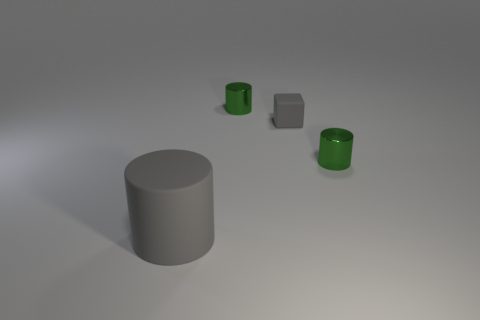Is the size of the gray cylinder the same as the gray cube?
Your answer should be very brief. No. Do the large cylinder and the small cylinder left of the block have the same material?
Keep it short and to the point. No. There is a matte thing that is on the right side of the gray cylinder; is its color the same as the matte cylinder?
Your answer should be compact. Yes. Is the green object that is behind the small rubber thing made of the same material as the small gray cube?
Keep it short and to the point. No. There is a metal thing that is in front of the small green cylinder that is behind the green metal thing on the right side of the tiny block; how big is it?
Provide a succinct answer. Small. There is a green cylinder on the right side of the tiny matte thing; how big is it?
Offer a terse response. Small. What is the material of the tiny green cylinder right of the small cylinder that is left of the small metallic cylinder on the right side of the small matte thing?
Offer a terse response. Metal. Is the green cylinder that is to the right of the gray rubber block made of the same material as the big gray object left of the block?
Ensure brevity in your answer.  No. There is a tiny cylinder in front of the small green metallic cylinder left of the tiny block; what is its color?
Give a very brief answer. Green. How many metal things are either cyan objects or large gray cylinders?
Provide a succinct answer. 0. 